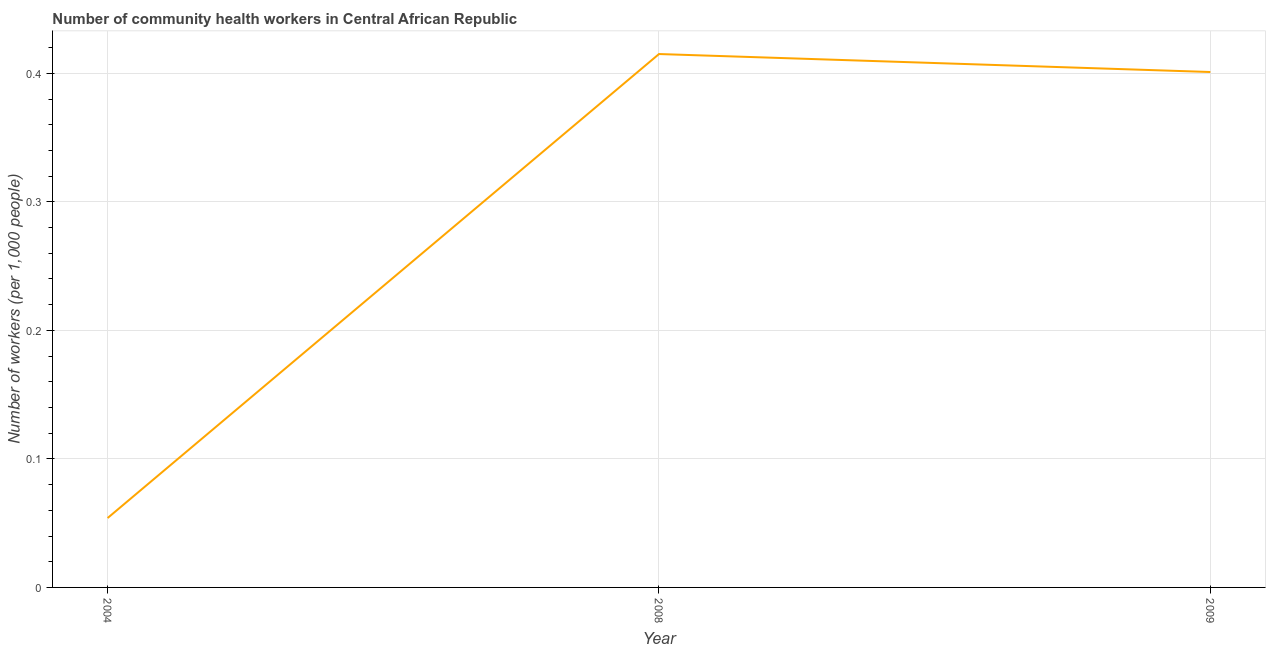What is the number of community health workers in 2004?
Provide a succinct answer. 0.05. Across all years, what is the maximum number of community health workers?
Your response must be concise. 0.41. Across all years, what is the minimum number of community health workers?
Provide a short and direct response. 0.05. What is the sum of the number of community health workers?
Keep it short and to the point. 0.87. What is the difference between the number of community health workers in 2004 and 2008?
Keep it short and to the point. -0.36. What is the average number of community health workers per year?
Make the answer very short. 0.29. What is the median number of community health workers?
Provide a short and direct response. 0.4. In how many years, is the number of community health workers greater than 0.34 ?
Provide a short and direct response. 2. Do a majority of the years between 2009 and 2004 (inclusive) have number of community health workers greater than 0.2 ?
Ensure brevity in your answer.  No. What is the ratio of the number of community health workers in 2004 to that in 2008?
Your response must be concise. 0.13. What is the difference between the highest and the second highest number of community health workers?
Give a very brief answer. 0.01. What is the difference between the highest and the lowest number of community health workers?
Your response must be concise. 0.36. How many years are there in the graph?
Offer a very short reply. 3. Are the values on the major ticks of Y-axis written in scientific E-notation?
Your answer should be compact. No. What is the title of the graph?
Your answer should be compact. Number of community health workers in Central African Republic. What is the label or title of the X-axis?
Offer a terse response. Year. What is the label or title of the Y-axis?
Offer a very short reply. Number of workers (per 1,0 people). What is the Number of workers (per 1,000 people) of 2004?
Give a very brief answer. 0.05. What is the Number of workers (per 1,000 people) of 2008?
Offer a terse response. 0.41. What is the Number of workers (per 1,000 people) of 2009?
Offer a terse response. 0.4. What is the difference between the Number of workers (per 1,000 people) in 2004 and 2008?
Offer a very short reply. -0.36. What is the difference between the Number of workers (per 1,000 people) in 2004 and 2009?
Your response must be concise. -0.35. What is the difference between the Number of workers (per 1,000 people) in 2008 and 2009?
Your answer should be compact. 0.01. What is the ratio of the Number of workers (per 1,000 people) in 2004 to that in 2008?
Provide a short and direct response. 0.13. What is the ratio of the Number of workers (per 1,000 people) in 2004 to that in 2009?
Offer a very short reply. 0.14. What is the ratio of the Number of workers (per 1,000 people) in 2008 to that in 2009?
Your answer should be very brief. 1.03. 